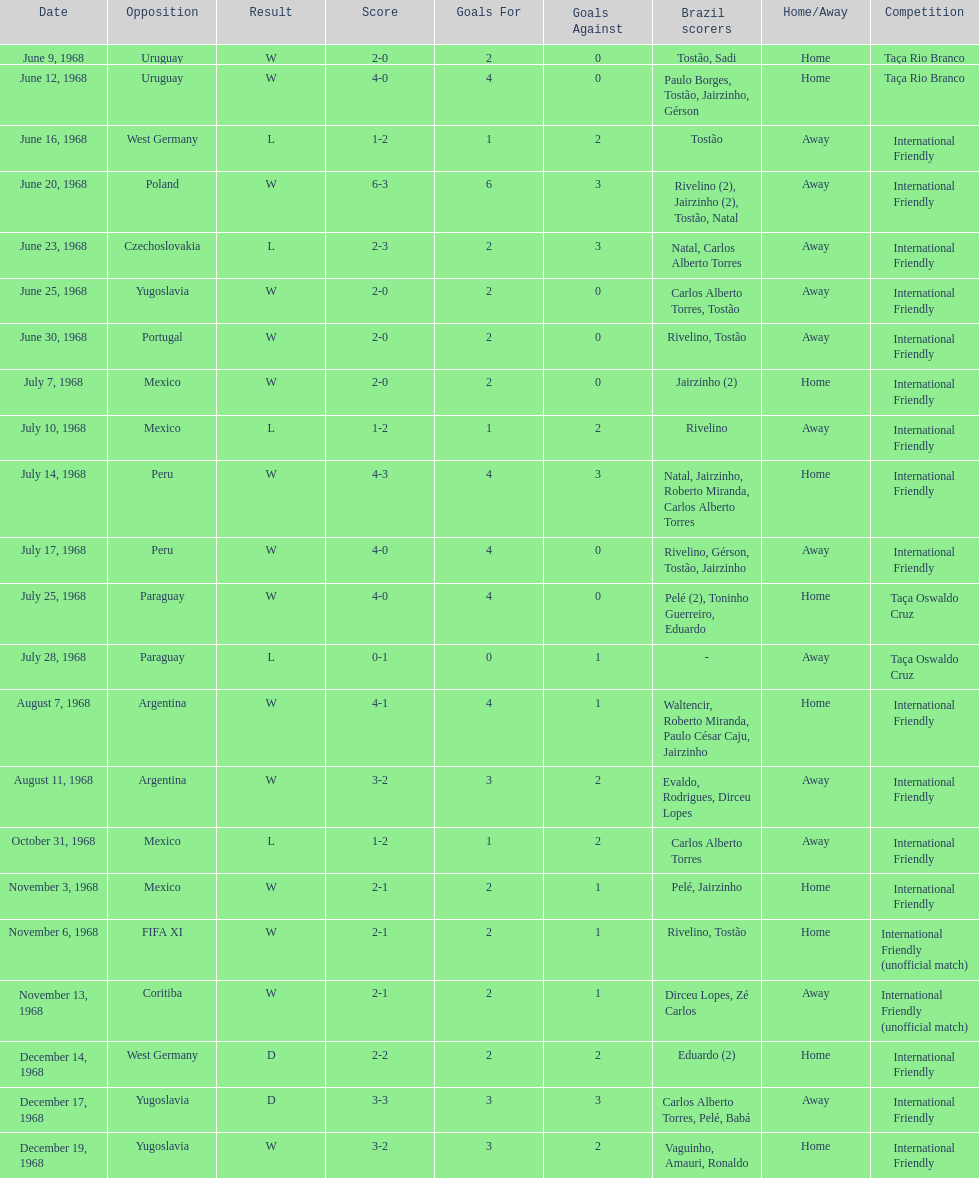How many times did brazil score during the game on november 6th? 2. 